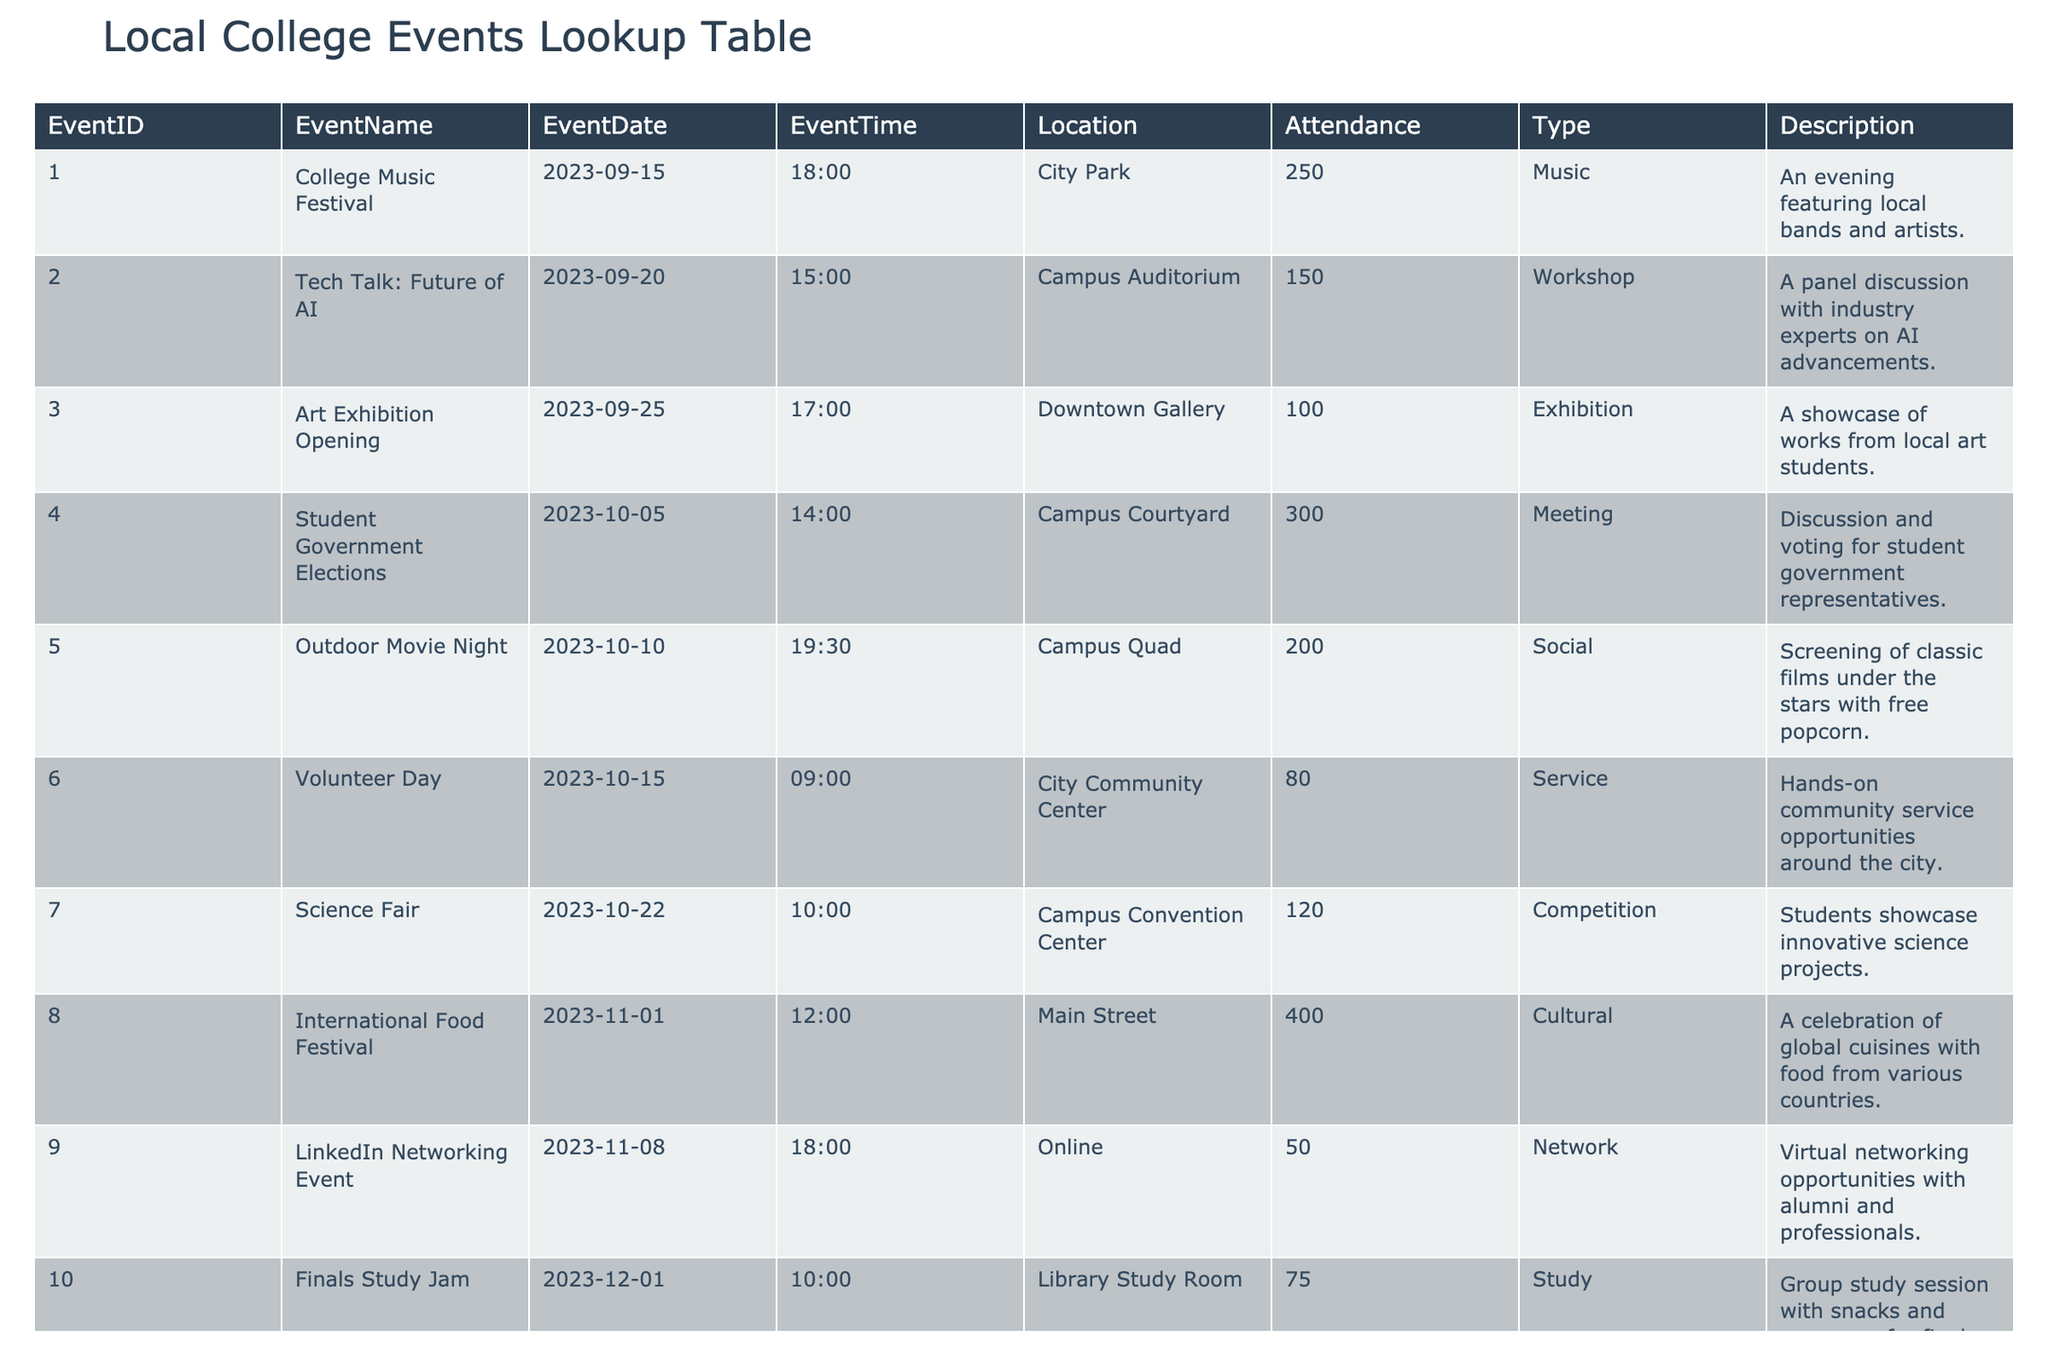What is the attendance for the College Music Festival? The table lists the event name "College Music Festival" with an attendance value next to it. Looking at the "Attendance" column for that event, the attendance is 250.
Answer: 250 Which event has the highest attendance? To find the highest attendance, we look through the "Attendance" column and identify the maximum value. The "International Food Festival" has the highest attendance of 400.
Answer: 400 What is the total attendance for all events? We sum the attendance figures for each event from the table: 250 + 150 + 100 + 300 + 200 + 80 + 120 + 400 + 50 + 75 = 1725. Thus, the total attendance is 1725.
Answer: 1725 Is the Finals Study Jam happening online? The table indicates the location for the "Finals Study Jam" event, which is "Library Study Room". Since this is a physical location and not online, the answer is no.
Answer: No How many events are scheduled after October 15, 2023? We look at the "EventDate" column and count the events that are scheduled after October 15, which includes the "Science Fair" on October 22, "International Food Festival" on November 1, "LinkedIn Networking Event" on November 8, and "Finals Study Jam" on December 1. There are 4 events in total.
Answer: 4 What event type has the lowest attendance? We need to find the lowest attendance value and its corresponding event type. The "Volunteer Day" has the lowest attendance of 80, making it the event type associated with the lowest attendance.
Answer: Service What is the average attendance for all Cultural events? We filter the table for events that are categorized as "Cultural", which is only the "International Food Festival" with an attendance of 400. Since there is just one cultural event, the average attendance is also 400.
Answer: 400 Is there an Art Exhibition Opening before the Student Government Elections? Comparing the dates in the table, the "Art Exhibition Opening" is on September 25, and the "Student Government Elections" is on October 5. Since September 25 is before October 5, the answer is yes.
Answer: Yes What percentage of the total attendance does the Tech Talk: Future of AI represent? First, find the attendance for "Tech Talk: Future of AI" which is 150. The total attendance calculated previously is 1725. To find the percentage: (150 / 1725) * 100 = 8.70%. Thus, the event represents approximately 8.70% of total attendance.
Answer: 8.70% 